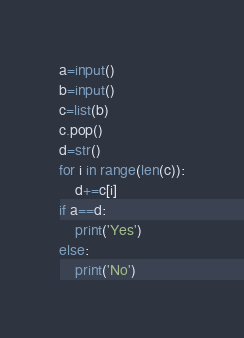Convert code to text. <code><loc_0><loc_0><loc_500><loc_500><_Python_>a=input()
b=input()
c=list(b)
c.pop()
d=str()
for i in range(len(c)):
    d+=c[i]
if a==d:
    print('Yes')
else:
    print('No')
</code> 